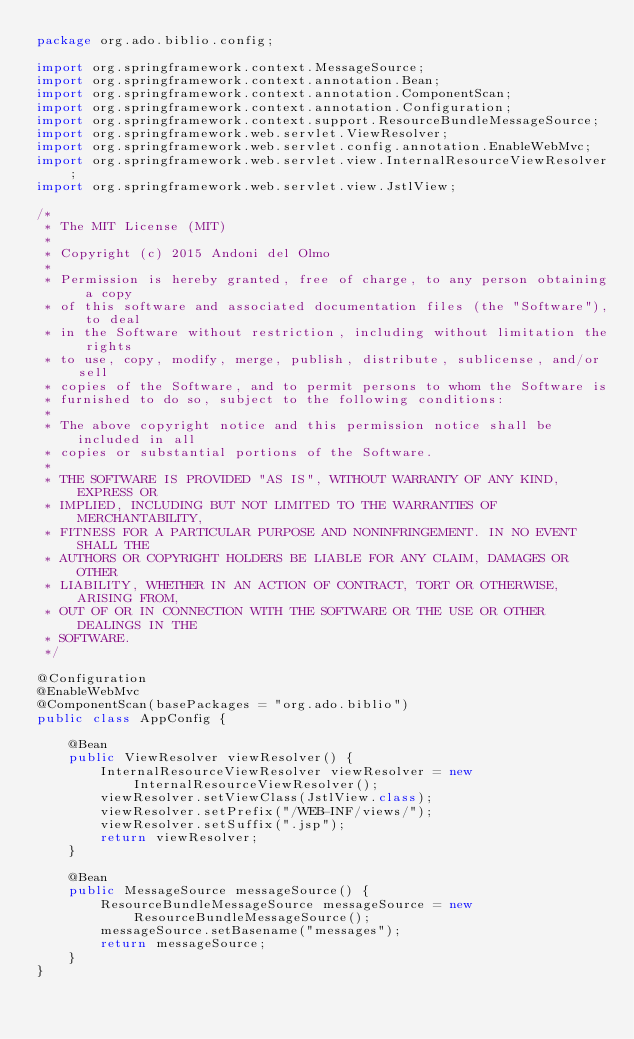Convert code to text. <code><loc_0><loc_0><loc_500><loc_500><_Java_>package org.ado.biblio.config;

import org.springframework.context.MessageSource;
import org.springframework.context.annotation.Bean;
import org.springframework.context.annotation.ComponentScan;
import org.springframework.context.annotation.Configuration;
import org.springframework.context.support.ResourceBundleMessageSource;
import org.springframework.web.servlet.ViewResolver;
import org.springframework.web.servlet.config.annotation.EnableWebMvc;
import org.springframework.web.servlet.view.InternalResourceViewResolver;
import org.springframework.web.servlet.view.JstlView;

/*
 * The MIT License (MIT)
 *
 * Copyright (c) 2015 Andoni del Olmo
 *
 * Permission is hereby granted, free of charge, to any person obtaining a copy
 * of this software and associated documentation files (the "Software"), to deal
 * in the Software without restriction, including without limitation the rights
 * to use, copy, modify, merge, publish, distribute, sublicense, and/or sell
 * copies of the Software, and to permit persons to whom the Software is
 * furnished to do so, subject to the following conditions:
 *
 * The above copyright notice and this permission notice shall be included in all
 * copies or substantial portions of the Software.
 *
 * THE SOFTWARE IS PROVIDED "AS IS", WITHOUT WARRANTY OF ANY KIND, EXPRESS OR
 * IMPLIED, INCLUDING BUT NOT LIMITED TO THE WARRANTIES OF MERCHANTABILITY,
 * FITNESS FOR A PARTICULAR PURPOSE AND NONINFRINGEMENT. IN NO EVENT SHALL THE
 * AUTHORS OR COPYRIGHT HOLDERS BE LIABLE FOR ANY CLAIM, DAMAGES OR OTHER
 * LIABILITY, WHETHER IN AN ACTION OF CONTRACT, TORT OR OTHERWISE, ARISING FROM,
 * OUT OF OR IN CONNECTION WITH THE SOFTWARE OR THE USE OR OTHER DEALINGS IN THE
 * SOFTWARE.
 */

@Configuration
@EnableWebMvc
@ComponentScan(basePackages = "org.ado.biblio")
public class AppConfig {

    @Bean
    public ViewResolver viewResolver() {
        InternalResourceViewResolver viewResolver = new InternalResourceViewResolver();
        viewResolver.setViewClass(JstlView.class);
        viewResolver.setPrefix("/WEB-INF/views/");
        viewResolver.setSuffix(".jsp");
        return viewResolver;
    }

    @Bean
    public MessageSource messageSource() {
        ResourceBundleMessageSource messageSource = new ResourceBundleMessageSource();
        messageSource.setBasename("messages");
        return messageSource;
    }
}</code> 